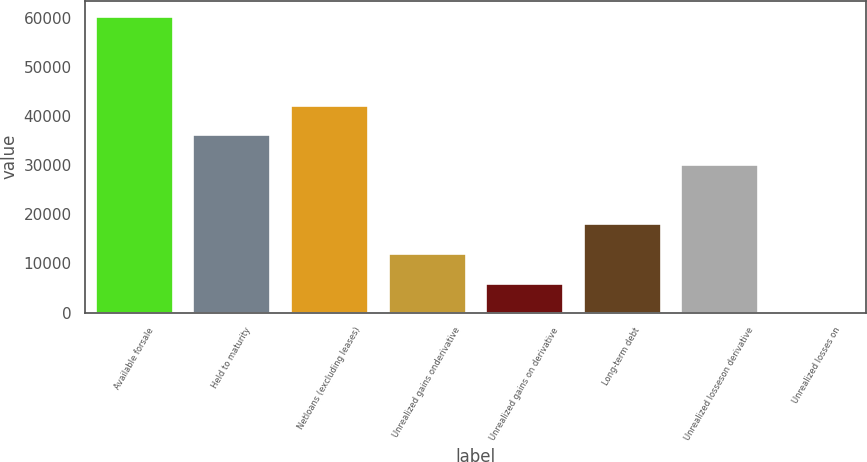Convert chart. <chart><loc_0><loc_0><loc_500><loc_500><bar_chart><fcel>Available forsale<fcel>Held to maturity<fcel>Netloans (excluding leases)<fcel>Unrealized gains onderivative<fcel>Unrealized gains on derivative<fcel>Long-term debt<fcel>Unrealized losseson derivative<fcel>Unrealized losses on<nl><fcel>60445<fcel>36279.4<fcel>42320.8<fcel>12113.8<fcel>6072.4<fcel>18155.2<fcel>30238<fcel>31<nl></chart> 